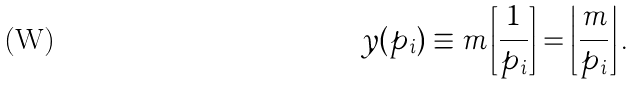<formula> <loc_0><loc_0><loc_500><loc_500>y ( p _ { i } ) \equiv m \left [ \frac { 1 } { p _ { i } } \right ] = \left \lfloor \frac { m } { p _ { i } } \right \rfloor .</formula> 